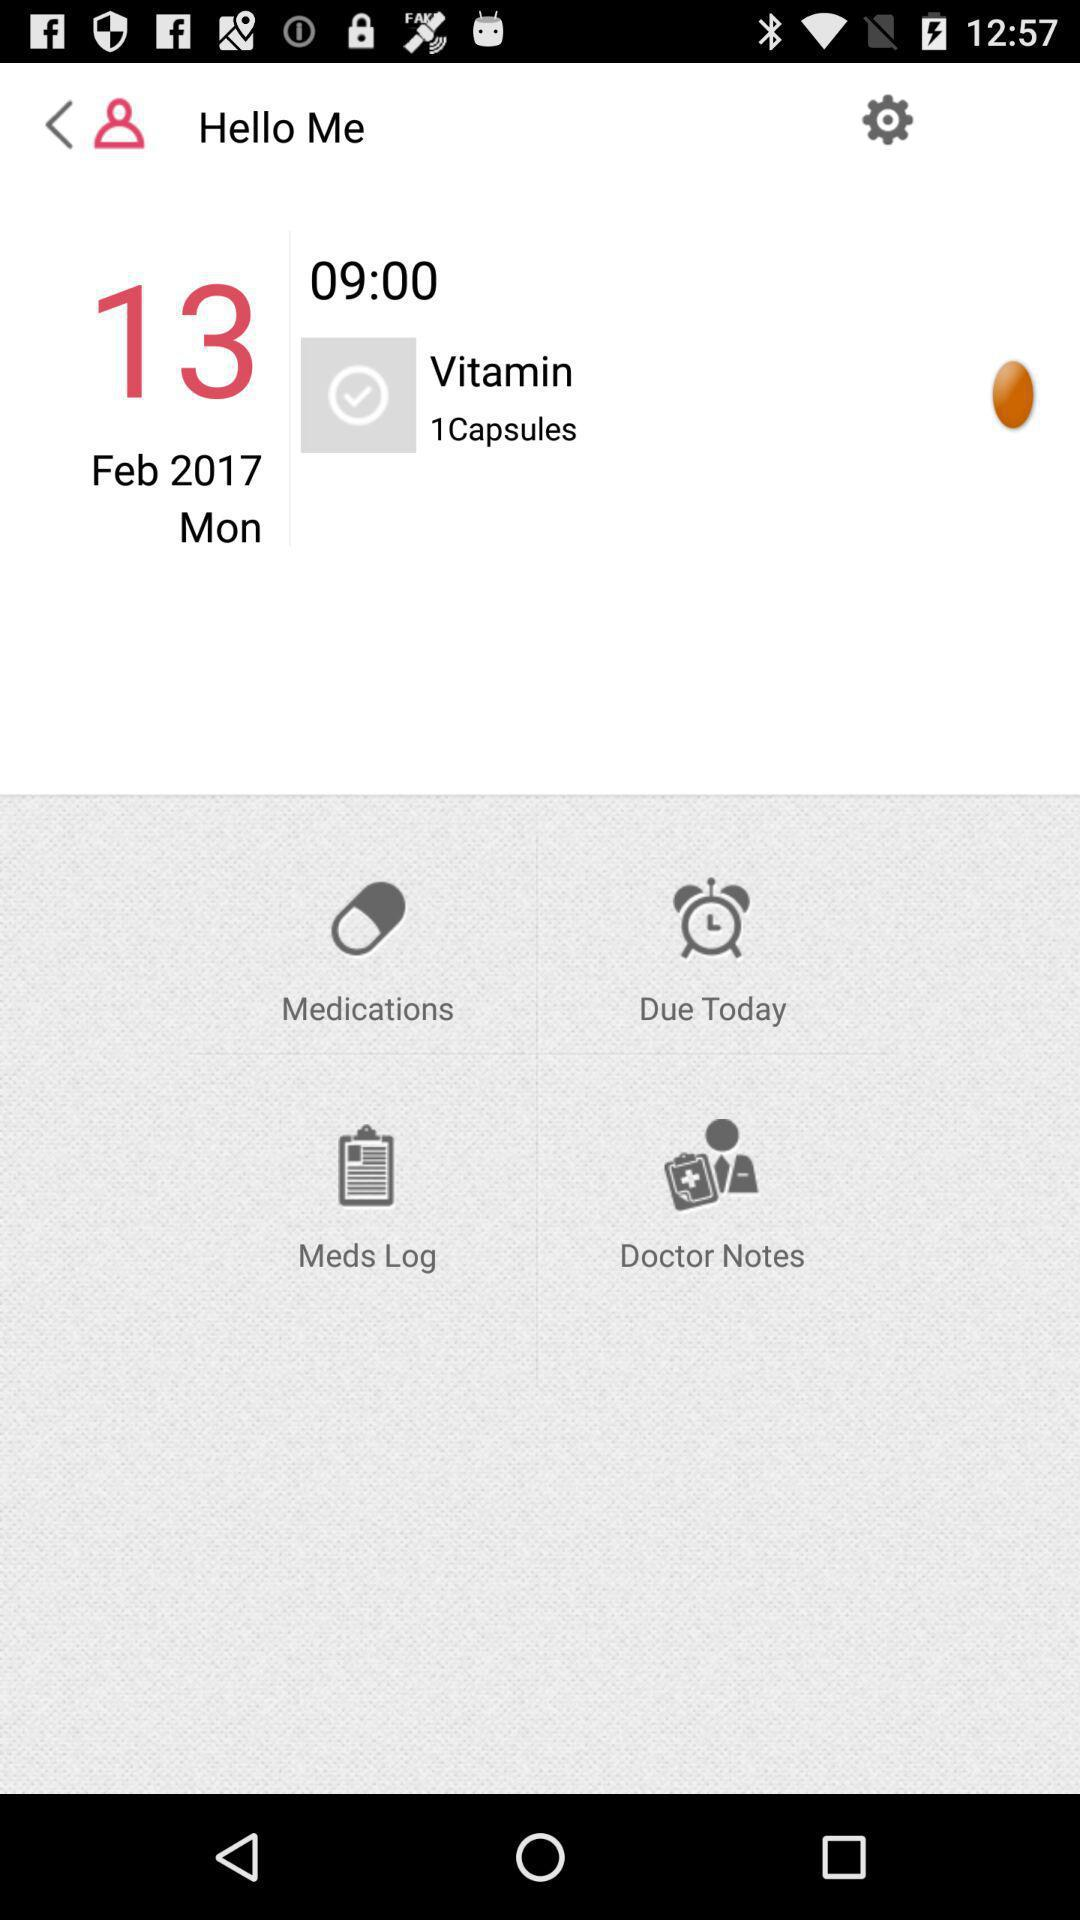What is the day on February 13? The day is Monday. 